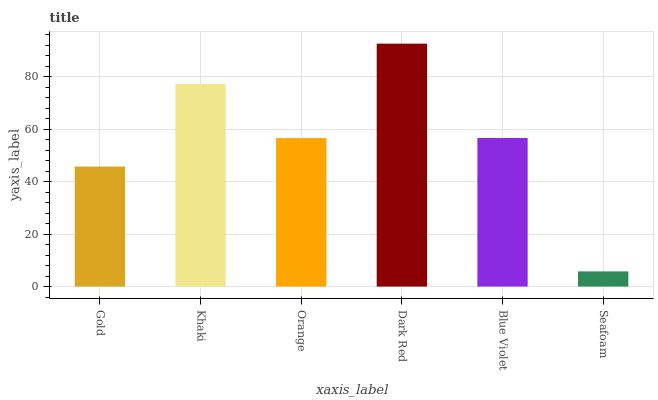Is Seafoam the minimum?
Answer yes or no. Yes. Is Dark Red the maximum?
Answer yes or no. Yes. Is Khaki the minimum?
Answer yes or no. No. Is Khaki the maximum?
Answer yes or no. No. Is Khaki greater than Gold?
Answer yes or no. Yes. Is Gold less than Khaki?
Answer yes or no. Yes. Is Gold greater than Khaki?
Answer yes or no. No. Is Khaki less than Gold?
Answer yes or no. No. Is Blue Violet the high median?
Answer yes or no. Yes. Is Orange the low median?
Answer yes or no. Yes. Is Seafoam the high median?
Answer yes or no. No. Is Blue Violet the low median?
Answer yes or no. No. 